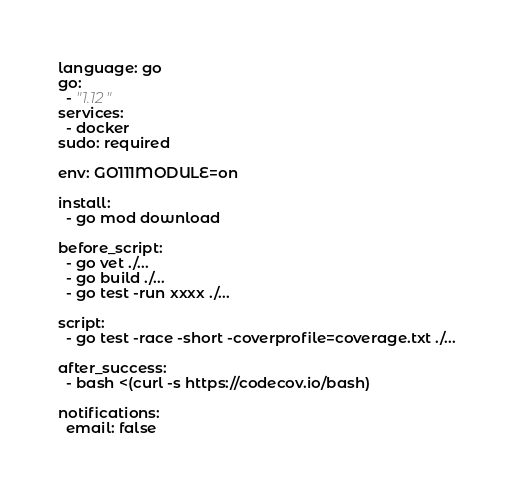Convert code to text. <code><loc_0><loc_0><loc_500><loc_500><_YAML_>language: go
go:
  - "1.12"
services:
  - docker
sudo: required

env: GO111MODULE=on 

install:
  - go mod download

before_script:
  - go vet ./...
  - go build ./...
  - go test -run xxxx ./...

script:
  - go test -race -short -coverprofile=coverage.txt ./...

after_success:
  - bash <(curl -s https://codecov.io/bash)

notifications: 
  email: false 
</code> 